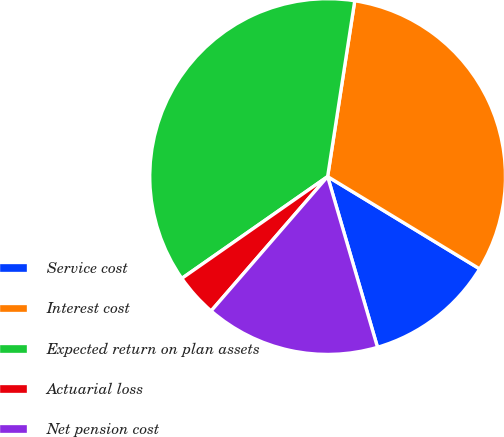Convert chart to OTSL. <chart><loc_0><loc_0><loc_500><loc_500><pie_chart><fcel>Service cost<fcel>Interest cost<fcel>Expected return on plan assets<fcel>Actuarial loss<fcel>Net pension cost<nl><fcel>11.79%<fcel>31.25%<fcel>37.14%<fcel>3.93%<fcel>15.89%<nl></chart> 